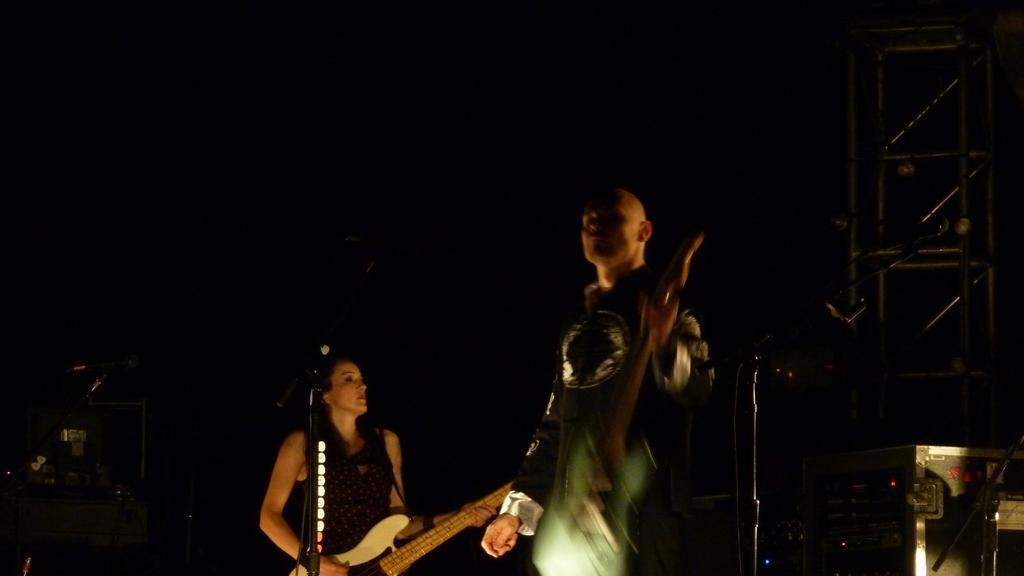Describe this image in one or two sentences. The person in the right is standing and holding a guitar and the women in the left is playing guitar. 